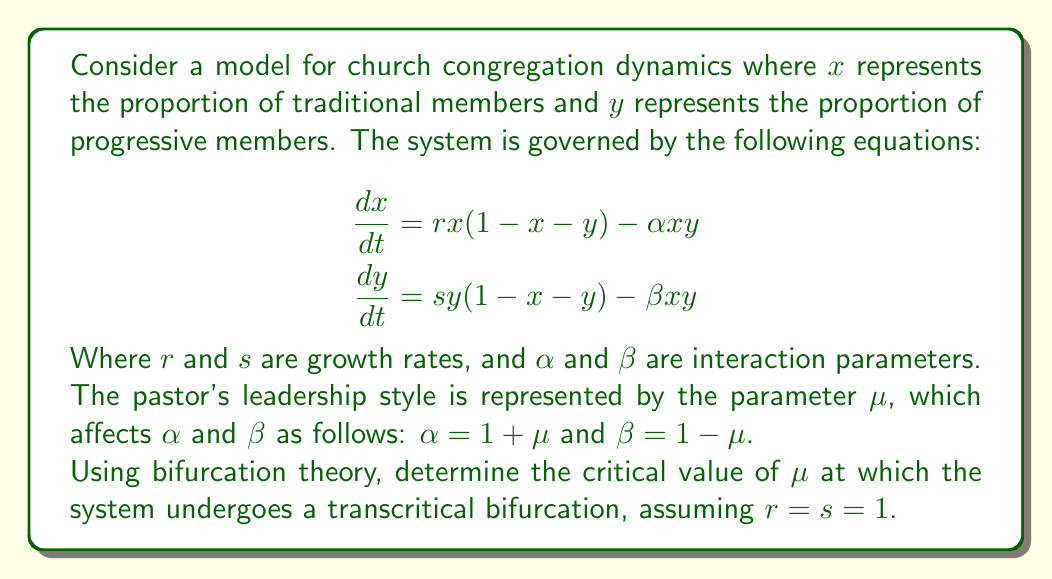Show me your answer to this math problem. To solve this problem, we'll follow these steps:

1) First, we need to find the equilibrium points of the system. At equilibrium, $\frac{dx}{dt} = \frac{dy}{dt} = 0$.

2) The trivial equilibrium point is $(0,0)$. We're interested in the non-trivial equilibrium points.

3) Setting $\frac{dx}{dt} = 0$ and $\frac{dy}{dt} = 0$:

   $$\begin{aligned}
   x(1-x-y) - (1+\mu)xy &= 0 \\
   y(1-x-y) - (1-\mu)xy &= 0
   \end{aligned}$$

4) Subtracting the second equation from the first:

   $x(1-x-y) - (1+\mu)xy - [y(1-x-y) - (1-\mu)xy] = 0$

5) Simplifying:

   $x - x^2 - xy - xy - \mu xy - y + xy + y^2 + xy - \mu xy = 0$
   $x - x^2 - y + y^2 - 2\mu xy = 0$

6) For a transcritical bifurcation, we're looking for the point where two equilibrium points exchange stability. This occurs when $x = y$.

7) Substituting $y = x$ into the equation from step 5:

   $x - x^2 - x + x^2 - 2\mu x^2 = 0$
   $-2\mu x^2 = 0$

8) This equation is satisfied when either $x = 0$ (the trivial equilibrium) or when $\mu = 0$.

9) Therefore, the transcritical bifurcation occurs at $\mu = 0$.

This bifurcation represents a change in the stability of the equilibrium points, which in the context of the congregation, could represent a shift in the balance between traditional and progressive members based on the pastor's leadership style.
Answer: $\mu = 0$ 